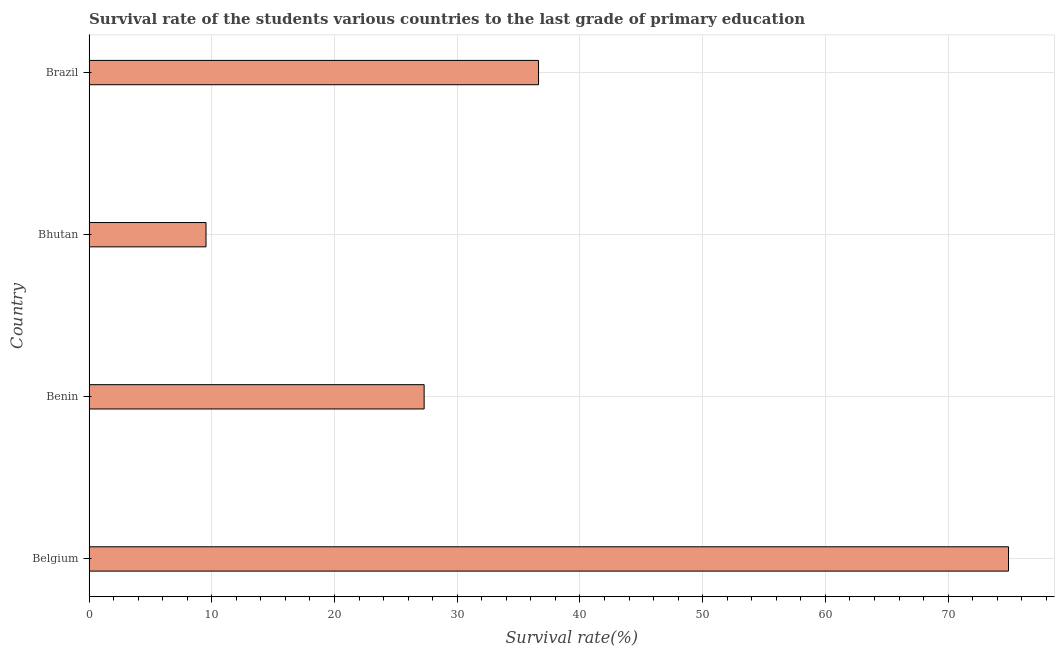Does the graph contain grids?
Ensure brevity in your answer.  Yes. What is the title of the graph?
Give a very brief answer. Survival rate of the students various countries to the last grade of primary education. What is the label or title of the X-axis?
Your answer should be compact. Survival rate(%). What is the label or title of the Y-axis?
Your answer should be very brief. Country. What is the survival rate in primary education in Bhutan?
Offer a terse response. 9.53. Across all countries, what is the maximum survival rate in primary education?
Give a very brief answer. 74.92. Across all countries, what is the minimum survival rate in primary education?
Ensure brevity in your answer.  9.53. In which country was the survival rate in primary education maximum?
Give a very brief answer. Belgium. In which country was the survival rate in primary education minimum?
Offer a very short reply. Bhutan. What is the sum of the survival rate in primary education?
Ensure brevity in your answer.  148.37. What is the difference between the survival rate in primary education in Belgium and Brazil?
Your response must be concise. 38.3. What is the average survival rate in primary education per country?
Make the answer very short. 37.09. What is the median survival rate in primary education?
Offer a terse response. 31.96. In how many countries, is the survival rate in primary education greater than 52 %?
Ensure brevity in your answer.  1. What is the ratio of the survival rate in primary education in Belgium to that in Bhutan?
Your answer should be compact. 7.86. Is the survival rate in primary education in Belgium less than that in Brazil?
Provide a short and direct response. No. Is the difference between the survival rate in primary education in Bhutan and Brazil greater than the difference between any two countries?
Offer a terse response. No. What is the difference between the highest and the second highest survival rate in primary education?
Keep it short and to the point. 38.3. Is the sum of the survival rate in primary education in Belgium and Brazil greater than the maximum survival rate in primary education across all countries?
Offer a very short reply. Yes. What is the difference between the highest and the lowest survival rate in primary education?
Offer a very short reply. 65.39. In how many countries, is the survival rate in primary education greater than the average survival rate in primary education taken over all countries?
Ensure brevity in your answer.  1. How many bars are there?
Make the answer very short. 4. Are all the bars in the graph horizontal?
Make the answer very short. Yes. How many countries are there in the graph?
Provide a short and direct response. 4. Are the values on the major ticks of X-axis written in scientific E-notation?
Ensure brevity in your answer.  No. What is the Survival rate(%) of Belgium?
Give a very brief answer. 74.92. What is the Survival rate(%) in Benin?
Offer a very short reply. 27.3. What is the Survival rate(%) in Bhutan?
Ensure brevity in your answer.  9.53. What is the Survival rate(%) in Brazil?
Your response must be concise. 36.62. What is the difference between the Survival rate(%) in Belgium and Benin?
Keep it short and to the point. 47.62. What is the difference between the Survival rate(%) in Belgium and Bhutan?
Offer a very short reply. 65.39. What is the difference between the Survival rate(%) in Belgium and Brazil?
Provide a short and direct response. 38.3. What is the difference between the Survival rate(%) in Benin and Bhutan?
Your response must be concise. 17.77. What is the difference between the Survival rate(%) in Benin and Brazil?
Offer a terse response. -9.32. What is the difference between the Survival rate(%) in Bhutan and Brazil?
Your response must be concise. -27.1. What is the ratio of the Survival rate(%) in Belgium to that in Benin?
Provide a succinct answer. 2.74. What is the ratio of the Survival rate(%) in Belgium to that in Bhutan?
Offer a terse response. 7.86. What is the ratio of the Survival rate(%) in Belgium to that in Brazil?
Provide a succinct answer. 2.05. What is the ratio of the Survival rate(%) in Benin to that in Bhutan?
Make the answer very short. 2.87. What is the ratio of the Survival rate(%) in Benin to that in Brazil?
Keep it short and to the point. 0.74. What is the ratio of the Survival rate(%) in Bhutan to that in Brazil?
Your answer should be very brief. 0.26. 